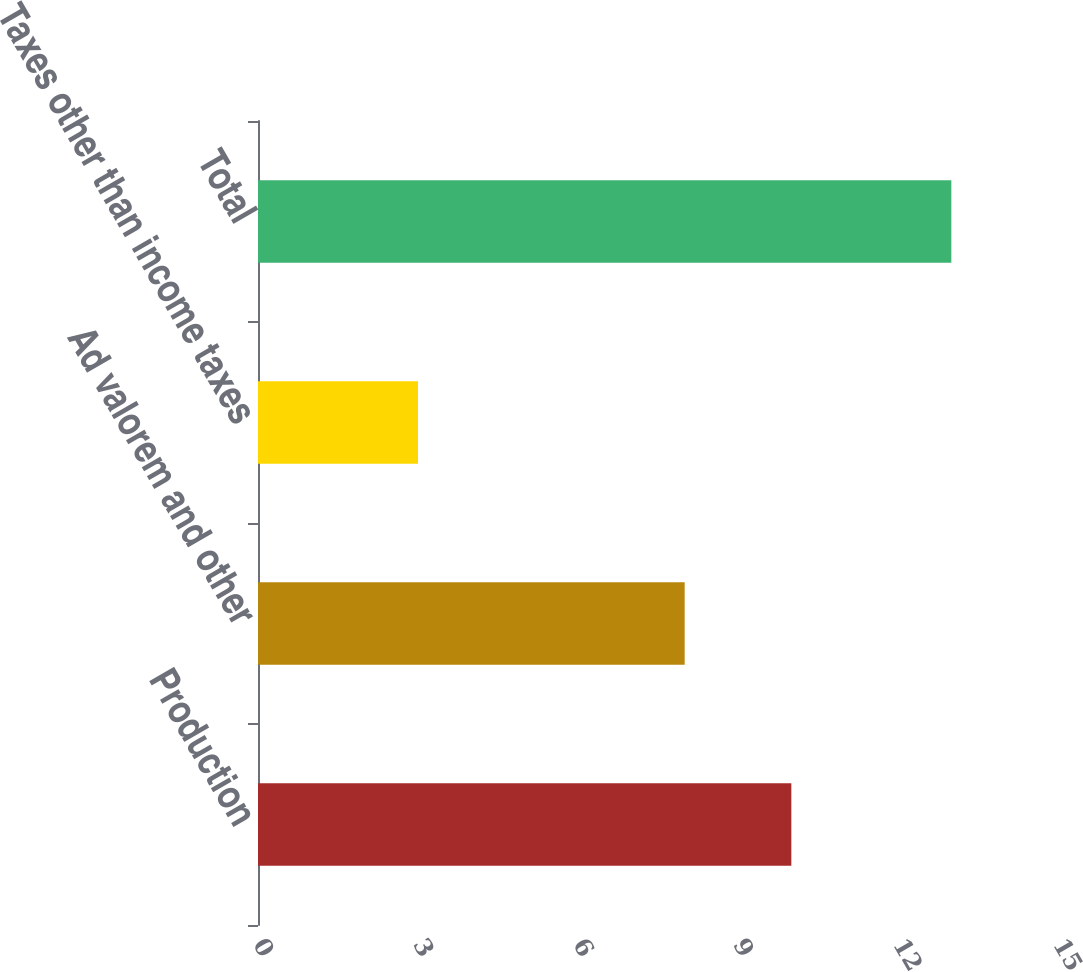<chart> <loc_0><loc_0><loc_500><loc_500><bar_chart><fcel>Production<fcel>Ad valorem and other<fcel>Taxes other than income taxes<fcel>Total<nl><fcel>10<fcel>8<fcel>3<fcel>13<nl></chart> 